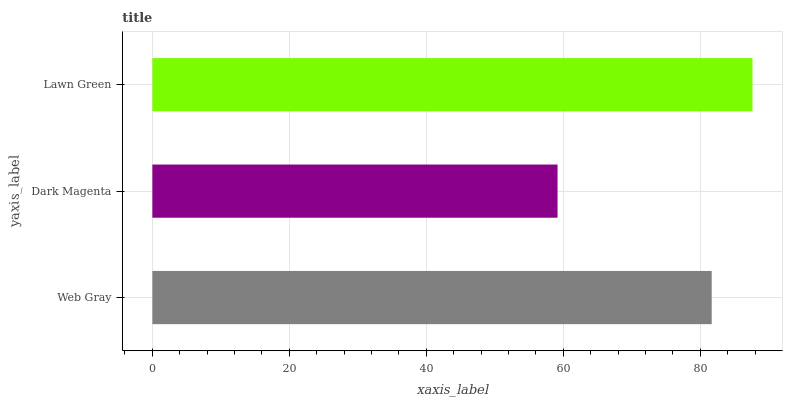Is Dark Magenta the minimum?
Answer yes or no. Yes. Is Lawn Green the maximum?
Answer yes or no. Yes. Is Lawn Green the minimum?
Answer yes or no. No. Is Dark Magenta the maximum?
Answer yes or no. No. Is Lawn Green greater than Dark Magenta?
Answer yes or no. Yes. Is Dark Magenta less than Lawn Green?
Answer yes or no. Yes. Is Dark Magenta greater than Lawn Green?
Answer yes or no. No. Is Lawn Green less than Dark Magenta?
Answer yes or no. No. Is Web Gray the high median?
Answer yes or no. Yes. Is Web Gray the low median?
Answer yes or no. Yes. Is Dark Magenta the high median?
Answer yes or no. No. Is Lawn Green the low median?
Answer yes or no. No. 